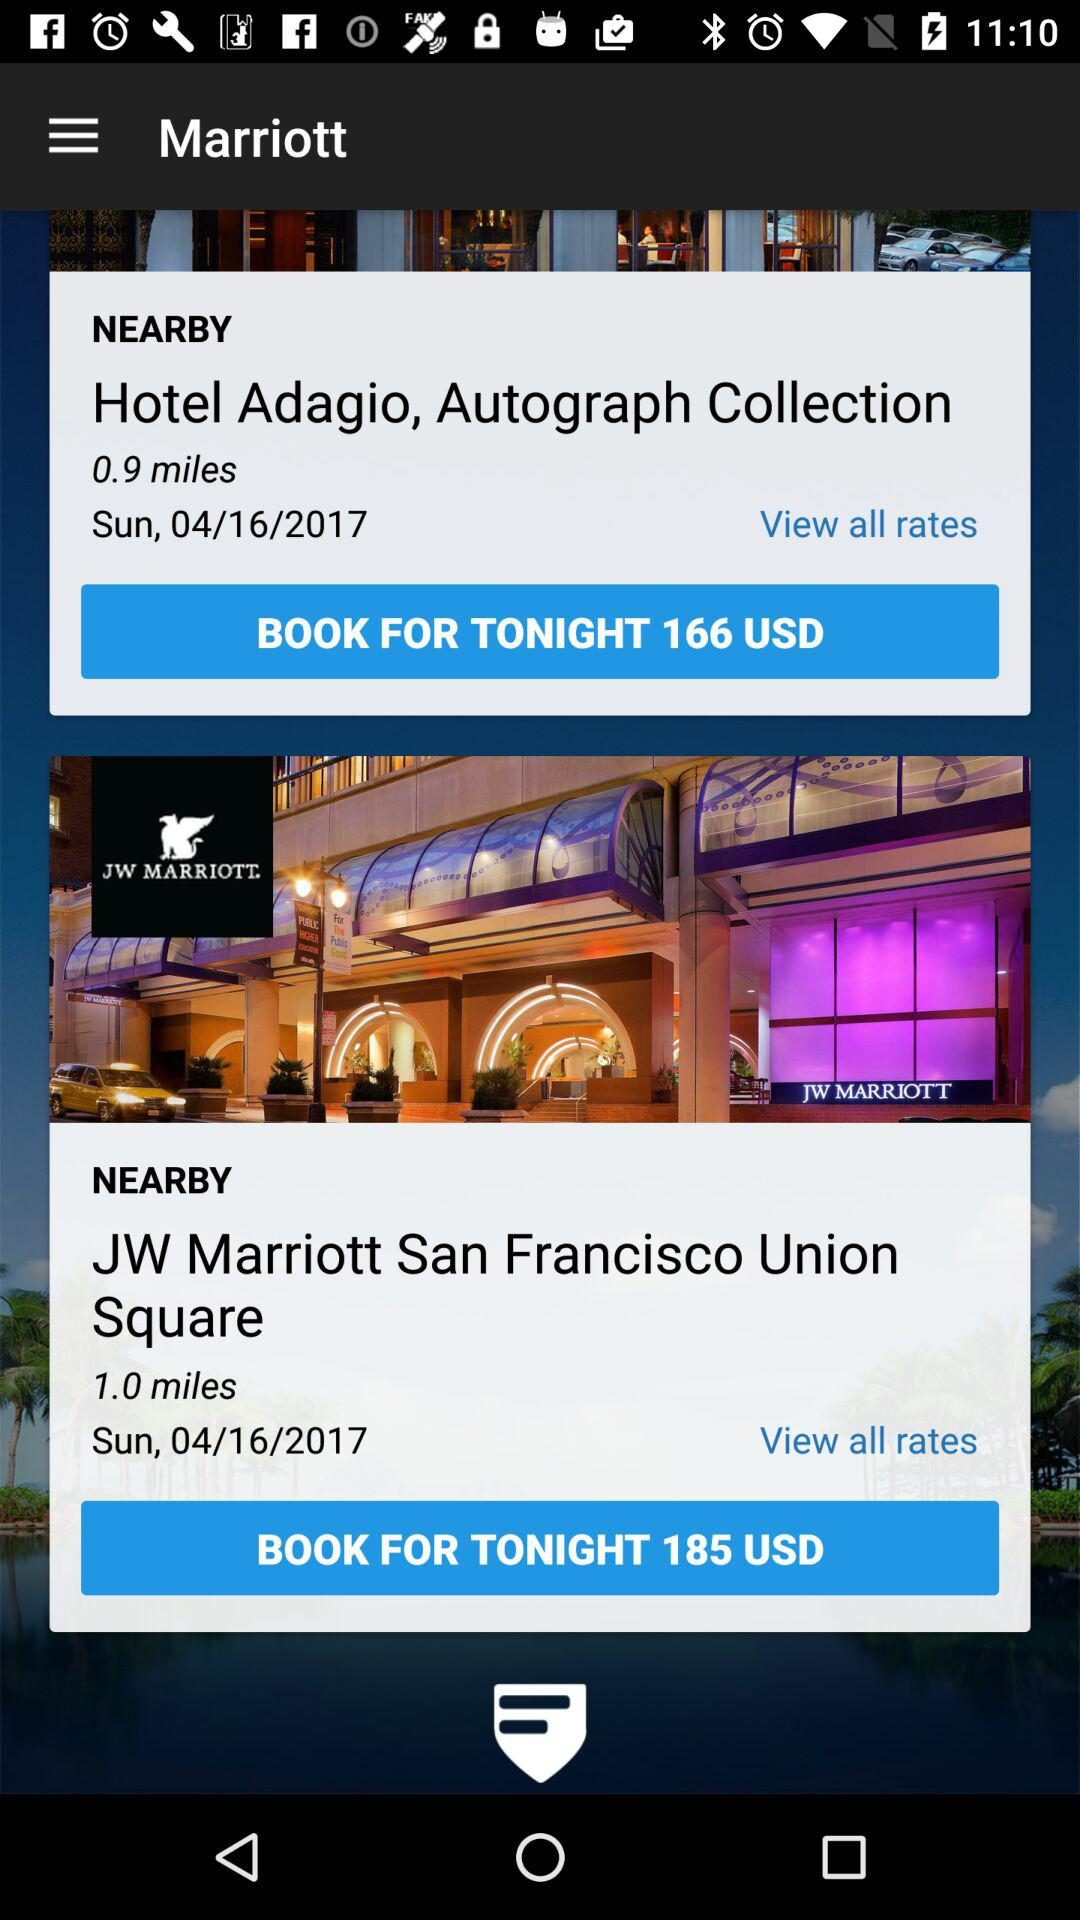Which are the nearby hotels? The nearby hotels are "Hotel Adagio" and "JW Marriott". 